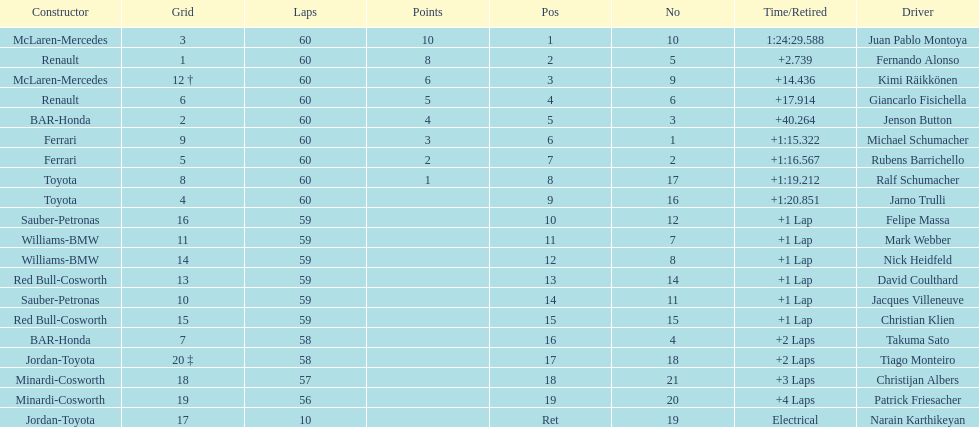How many drivers received points from the race? 8. 